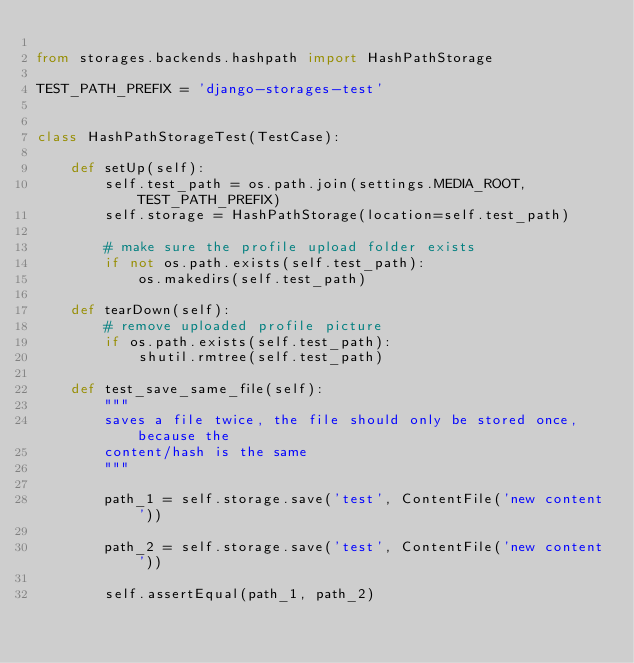Convert code to text. <code><loc_0><loc_0><loc_500><loc_500><_Python_>
from storages.backends.hashpath import HashPathStorage

TEST_PATH_PREFIX = 'django-storages-test'


class HashPathStorageTest(TestCase):

    def setUp(self):
        self.test_path = os.path.join(settings.MEDIA_ROOT, TEST_PATH_PREFIX)
        self.storage = HashPathStorage(location=self.test_path)

        # make sure the profile upload folder exists
        if not os.path.exists(self.test_path):
            os.makedirs(self.test_path)

    def tearDown(self):
        # remove uploaded profile picture
        if os.path.exists(self.test_path):
            shutil.rmtree(self.test_path)

    def test_save_same_file(self):
        """
        saves a file twice, the file should only be stored once, because the
        content/hash is the same
        """
        
        path_1 = self.storage.save('test', ContentFile('new content'))
        
        path_2 = self.storage.save('test', ContentFile('new content'))

        self.assertEqual(path_1, path_2)
</code> 